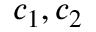Convert formula to latex. <formula><loc_0><loc_0><loc_500><loc_500>c _ { 1 } , c _ { 2 }</formula> 